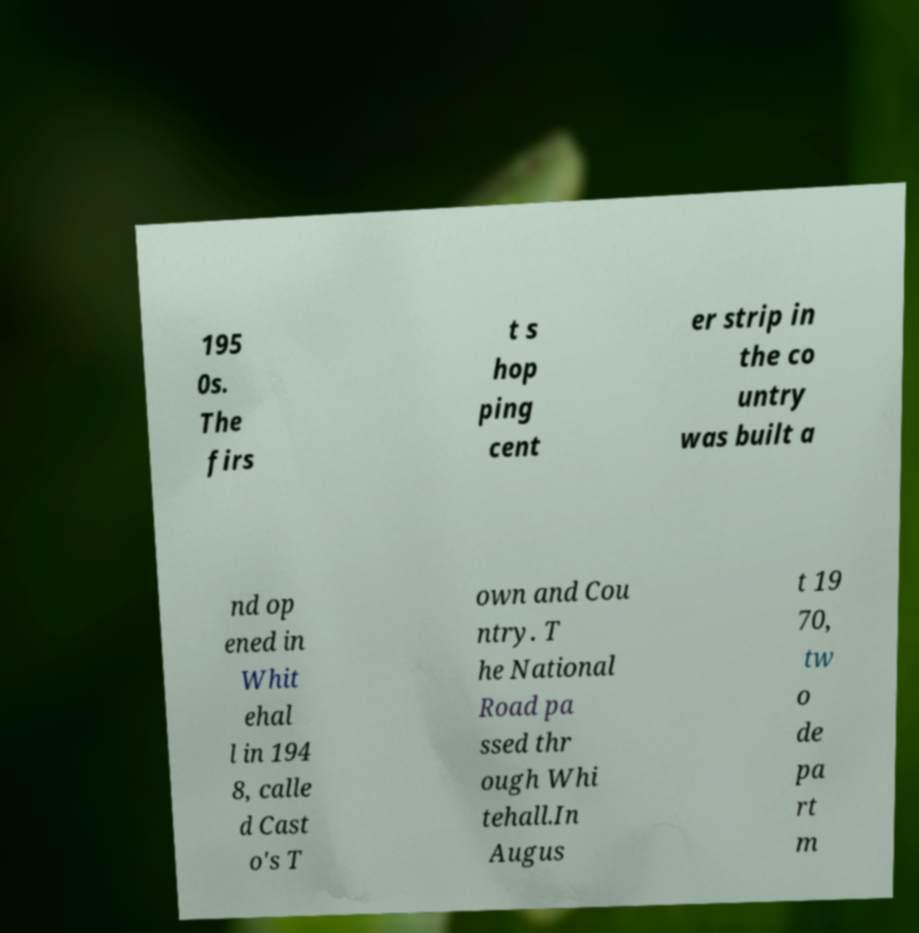Could you assist in decoding the text presented in this image and type it out clearly? 195 0s. The firs t s hop ping cent er strip in the co untry was built a nd op ened in Whit ehal l in 194 8, calle d Cast o's T own and Cou ntry. T he National Road pa ssed thr ough Whi tehall.In Augus t 19 70, tw o de pa rt m 